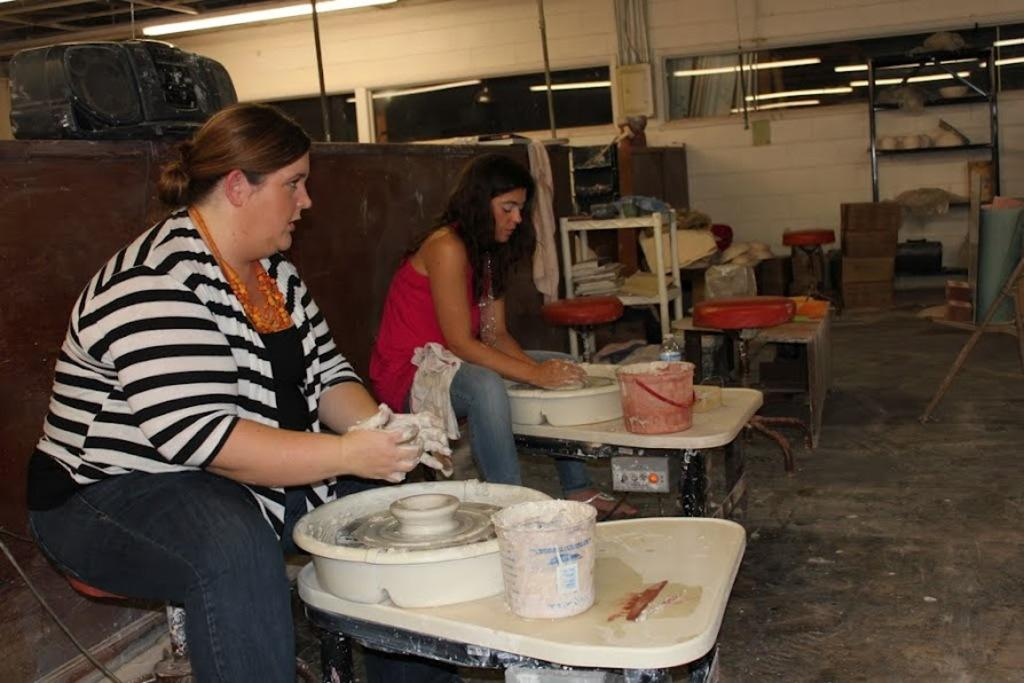What is present in the image that serves as a background or barrier? There is a wall in the image. How many people can be seen in the image? There are two people sitting in the image. What is located in front of the people? There is a table in front of the people. What items are on the table? There is a bucket and a tray on the table. Can you tell me what type of wallpaper is on the wall in the image? There is no information about the wallpaper on the wall in the image. What order are the people sitting in? The image does not provide information about the order in which the people are sitting. 